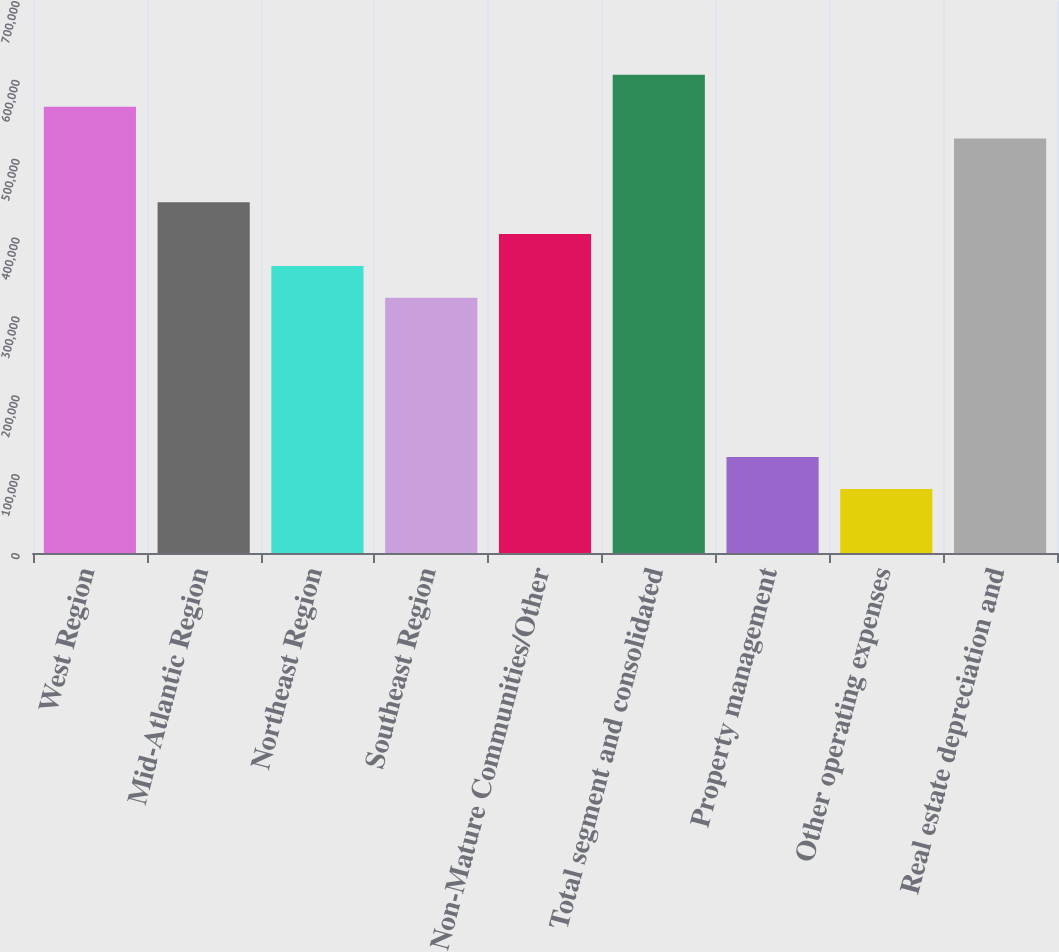Convert chart. <chart><loc_0><loc_0><loc_500><loc_500><bar_chart><fcel>West Region<fcel>Mid-Atlantic Region<fcel>Northeast Region<fcel>Southeast Region<fcel>Non-Mature Communities/Other<fcel>Total segment and consolidated<fcel>Property management<fcel>Other operating expenses<fcel>Real estate depreciation and<nl><fcel>565987<fcel>444808<fcel>364022<fcel>323629<fcel>404415<fcel>606380<fcel>121663<fcel>81270.2<fcel>525594<nl></chart> 